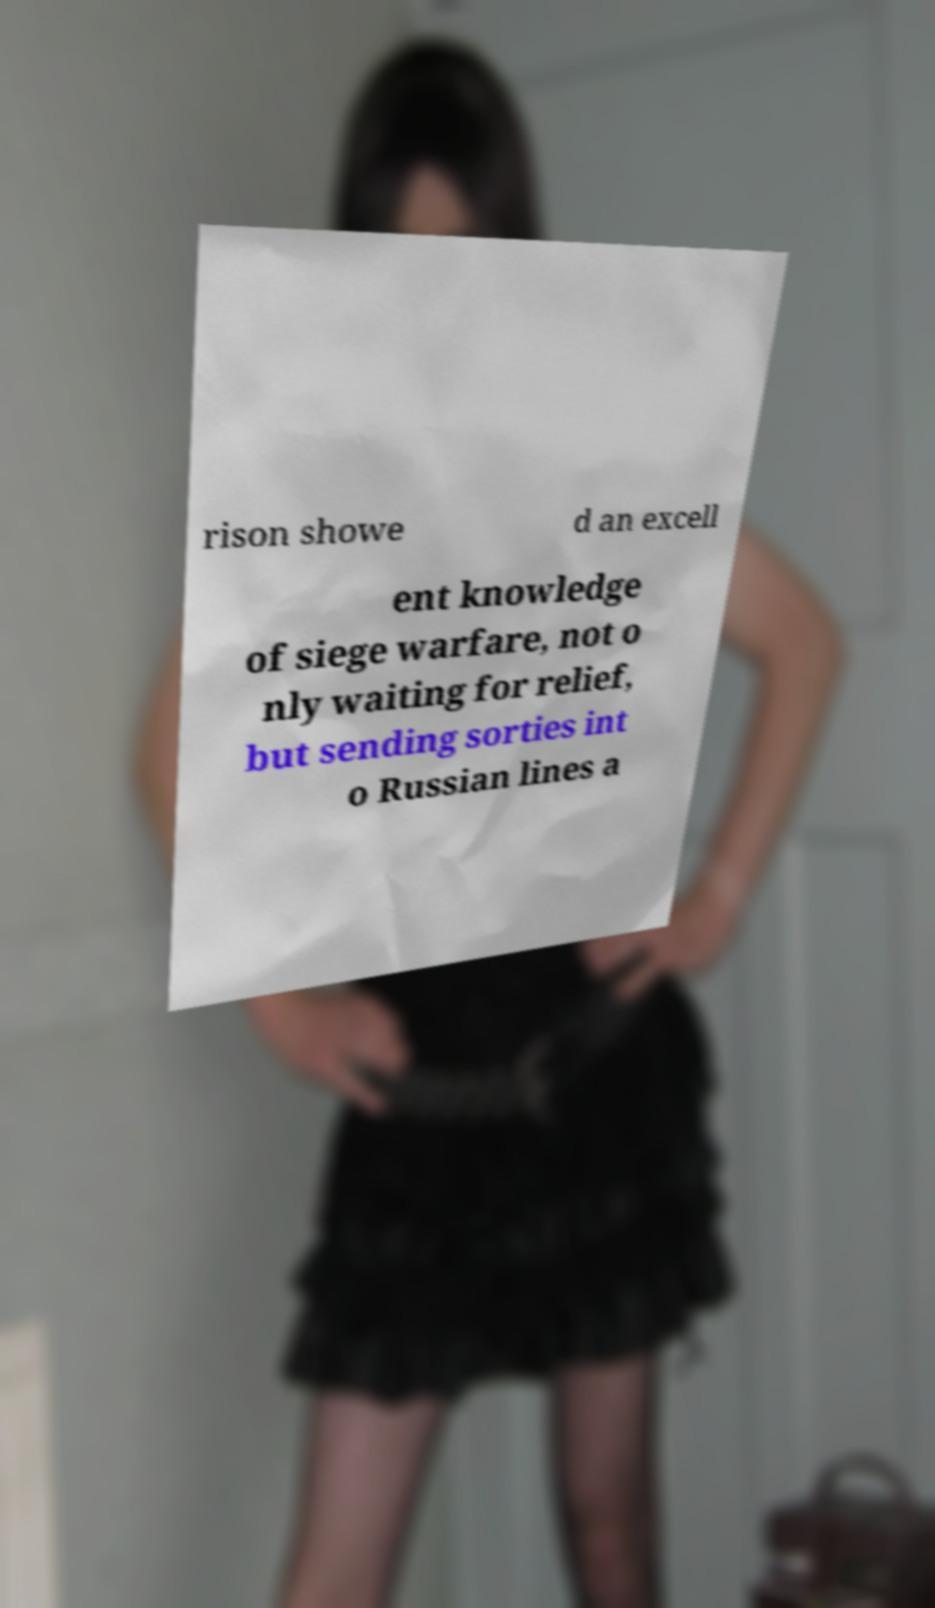I need the written content from this picture converted into text. Can you do that? rison showe d an excell ent knowledge of siege warfare, not o nly waiting for relief, but sending sorties int o Russian lines a 